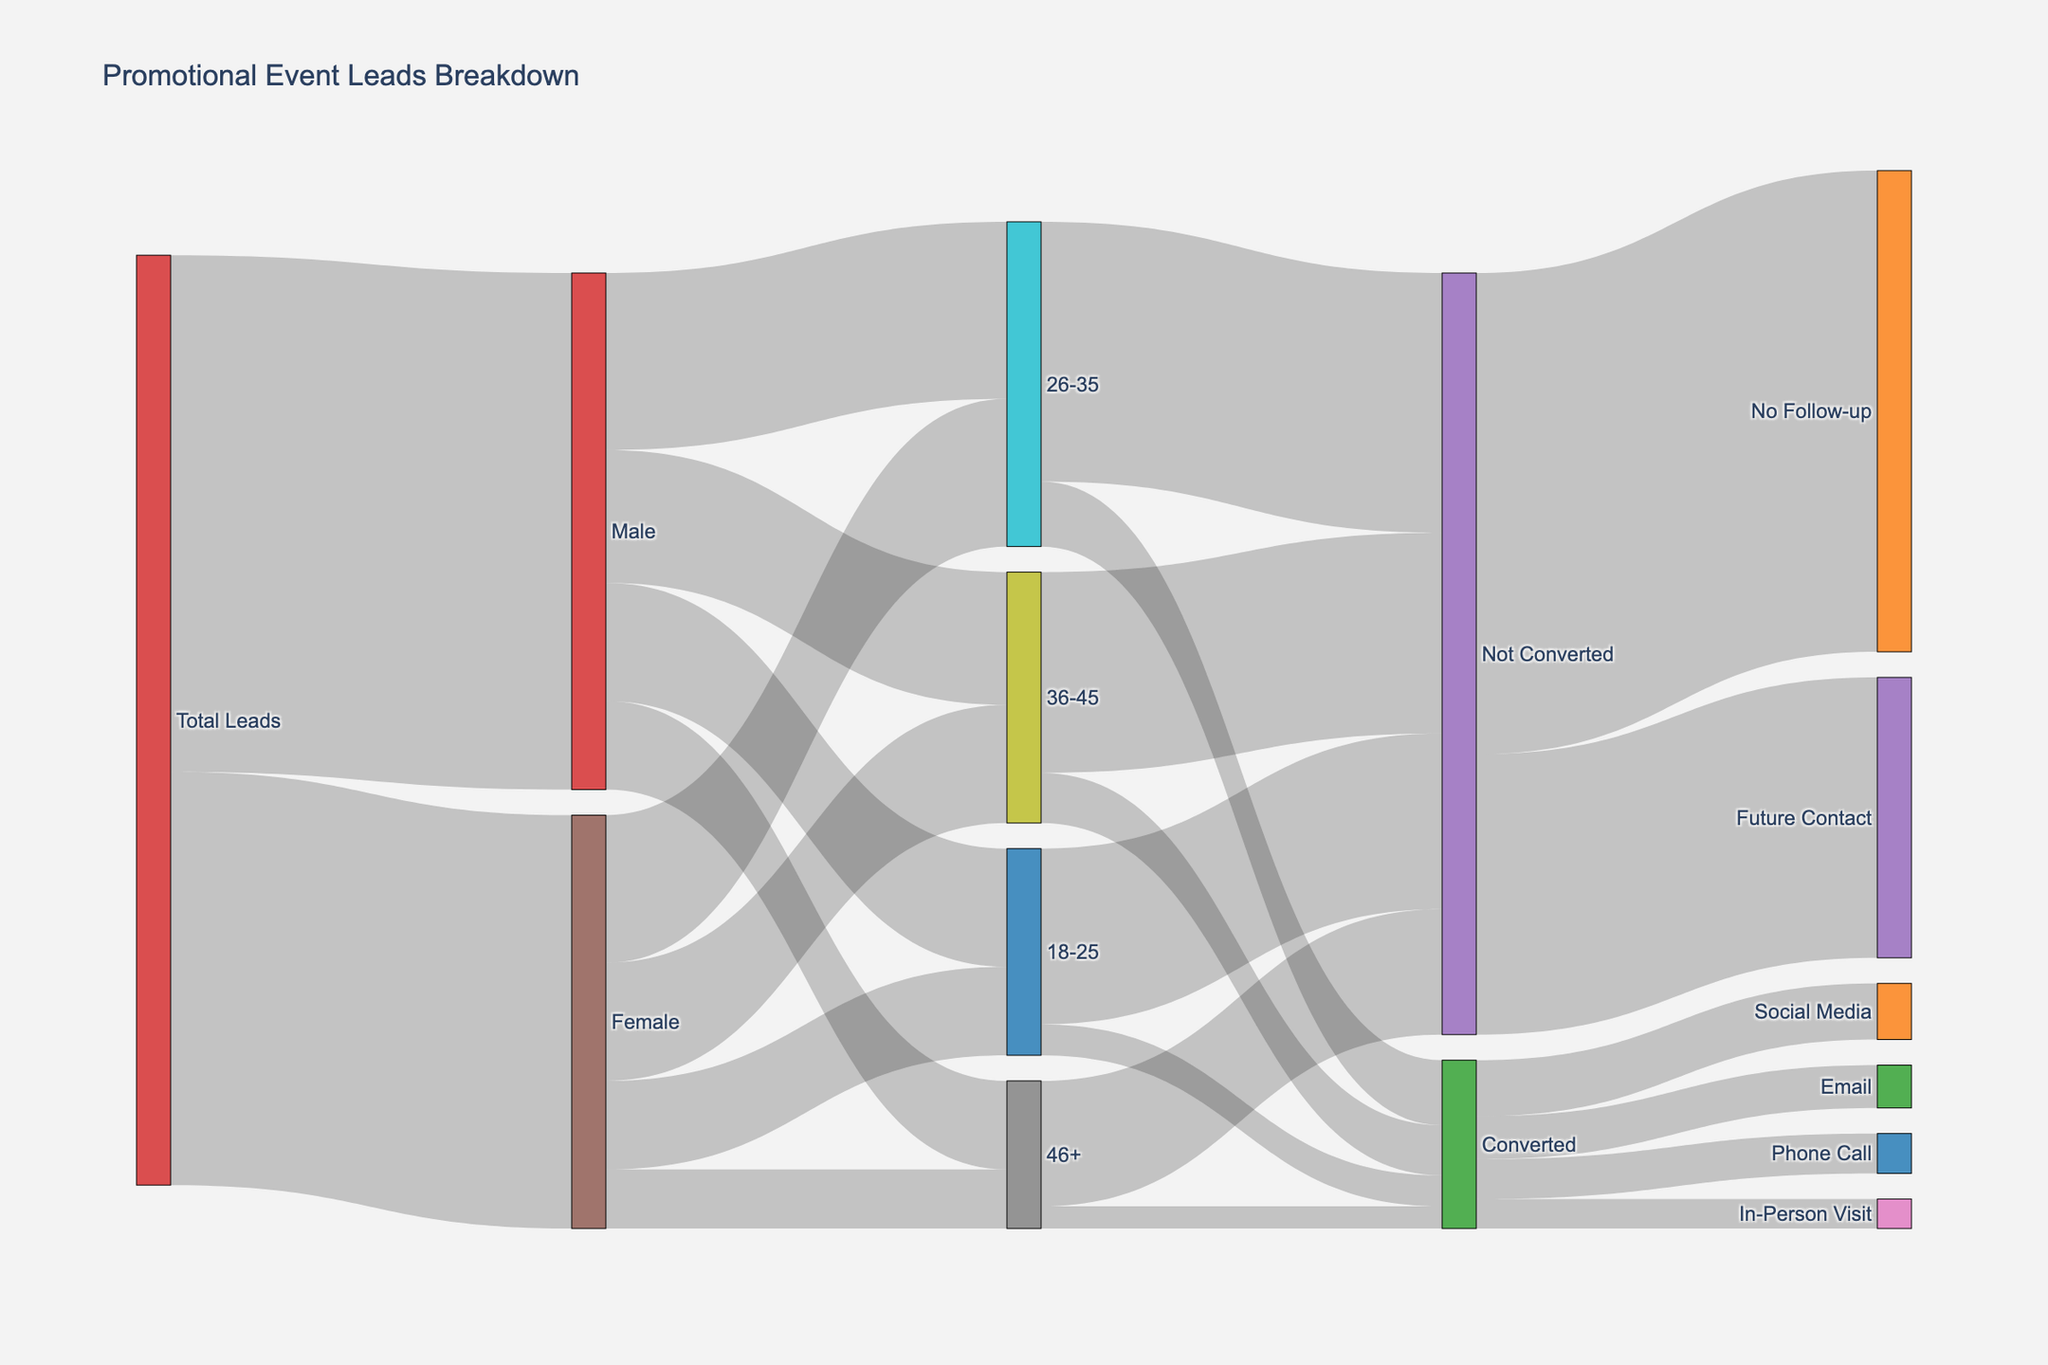What is the total number of leads generated? Add the number of leads for both males and females.
Answer: 6300 How many 26-35 year-old leads were converted? Refer to the flow from the "26-35" node to the "Converted" node.
Answer: 440 Which method had the highest number of conversions? Compare the flow values from the "Converted" node to each method (Social Media, Email, Phone Call, In-Person Visit) and identify the highest value, which is Social Media with 380 leads.
Answer: Social Media What is the total number of non-converted leads aged 36-45? Refer to the flow from the "36-45" node to the "Not Converted" node.
Answer: 1360 Which gender has more leads? Compare the values flowing from the "Total Leads" node to the "Male" and "Female" nodes respectively.
Answer: Male What is the percentage of leads that are female? Divide the number of female leads by the total number of leads and multiply by 100. The number of female leads is 2800, and the total number of leads is 6300. Calculation: (2800/6300) * 100 = 44.44%.
Answer: 44.44% How many of the converted 18-25 year-olds used social media for follow-up? The diagram does not provide this level of detailed breakdown. However, refer to the flow from "Converted" to "Social Media" and consider what percentage might be from 18-25 if you need to speculate.
Answer: Not specified in the diagram Between which two age groups is there the smallest difference in the number of conversions? Calculate the difference in conversions between each consecutive age group: 
- 18-25 and 26-35: 440 - 210 = 230
- 26-35 and 36-45: 340 - 440 = 100
- 36-45 and 46+: 150 - 340 = 190
The smallest difference is between 26-35 and 36-45, which is 100.
Answer: 26-35 and 36-45 What proportion of non-converted leads will be contacted in the future? Divide the number of non-converted leads marked for future contact by the total number of non-converted leads: 1900/5160 ≈ 0.368 or 36.8%.
Answer: 36.8% What is the most common age group among male leads? Compare the flow values from "Male" to each age group and identify the highest value, which is 26-35 with 1200 leads.
Answer: 26-35 